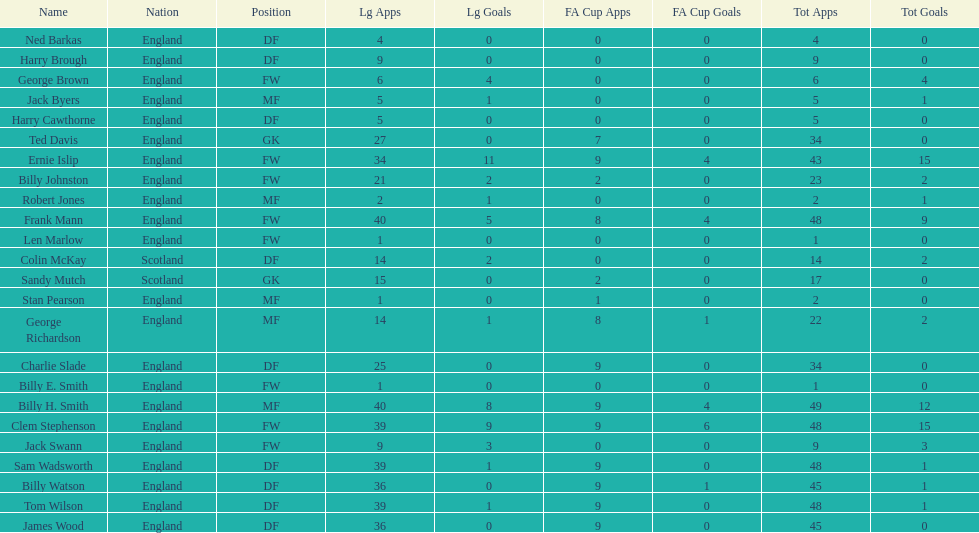What is the last name listed on this chart? James Wood. 